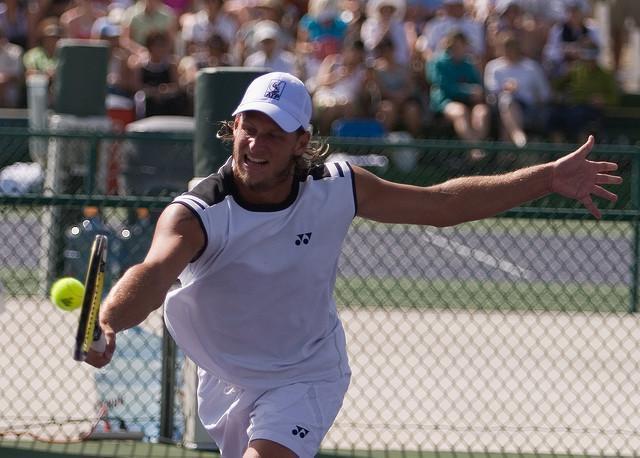How many people are there?
Give a very brief answer. 10. 